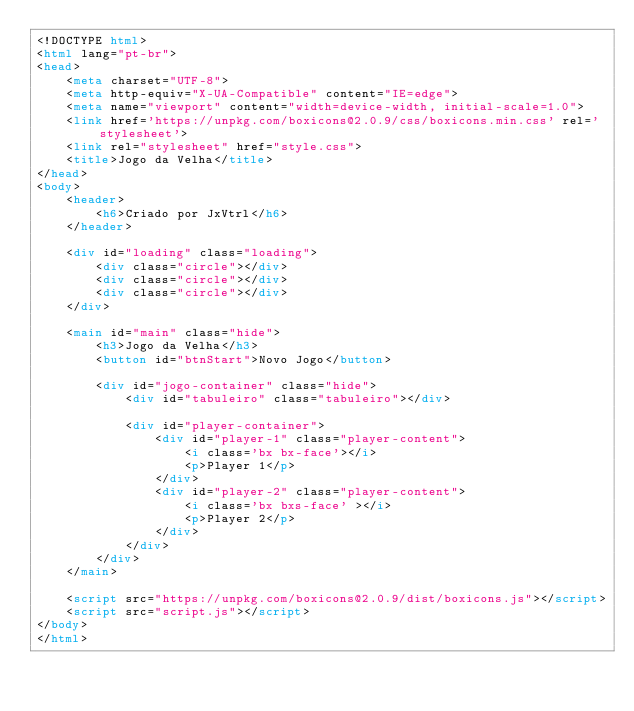Convert code to text. <code><loc_0><loc_0><loc_500><loc_500><_HTML_><!DOCTYPE html>
<html lang="pt-br">
<head>
    <meta charset="UTF-8">
    <meta http-equiv="X-UA-Compatible" content="IE=edge">
    <meta name="viewport" content="width=device-width, initial-scale=1.0">
    <link href='https://unpkg.com/boxicons@2.0.9/css/boxicons.min.css' rel='stylesheet'>
    <link rel="stylesheet" href="style.css">
    <title>Jogo da Velha</title>
</head>
<body>
    <header>
        <h6>Criado por JxVtrl</h6>
    </header>

    <div id="loading" class="loading">
        <div class="circle"></div>
        <div class="circle"></div>
        <div class="circle"></div>
    </div>

    <main id="main" class="hide">
        <h3>Jogo da Velha</h3>
        <button id="btnStart">Novo Jogo</button>

        <div id="jogo-container" class="hide">
            <div id="tabuleiro" class="tabuleiro"></div>

            <div id="player-container">
                <div id="player-1" class="player-content">
                    <i class='bx bx-face'></i>
                    <p>Player 1</p>
                </div>
                <div id="player-2" class="player-content">
                    <i class='bx bxs-face' ></i>
                    <p>Player 2</p>
                </div>
            </div>
        </div>
    </main>

    <script src="https://unpkg.com/boxicons@2.0.9/dist/boxicons.js"></script> 
    <script src="script.js"></script>
</body>
</html></code> 